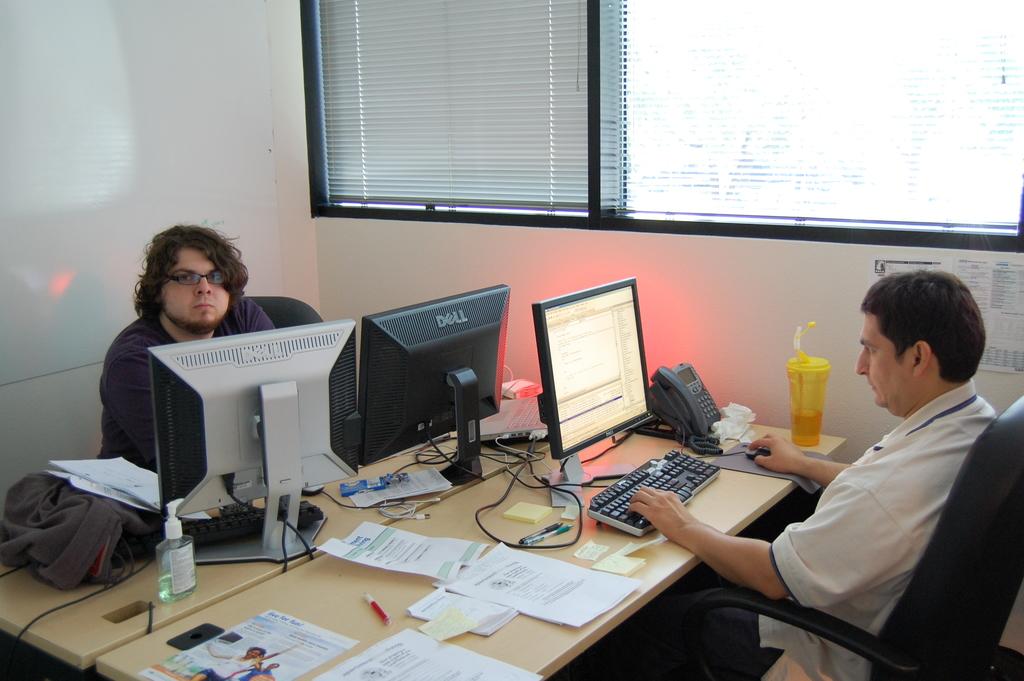Who made the center computer monitor?
Offer a very short reply. Dell. 